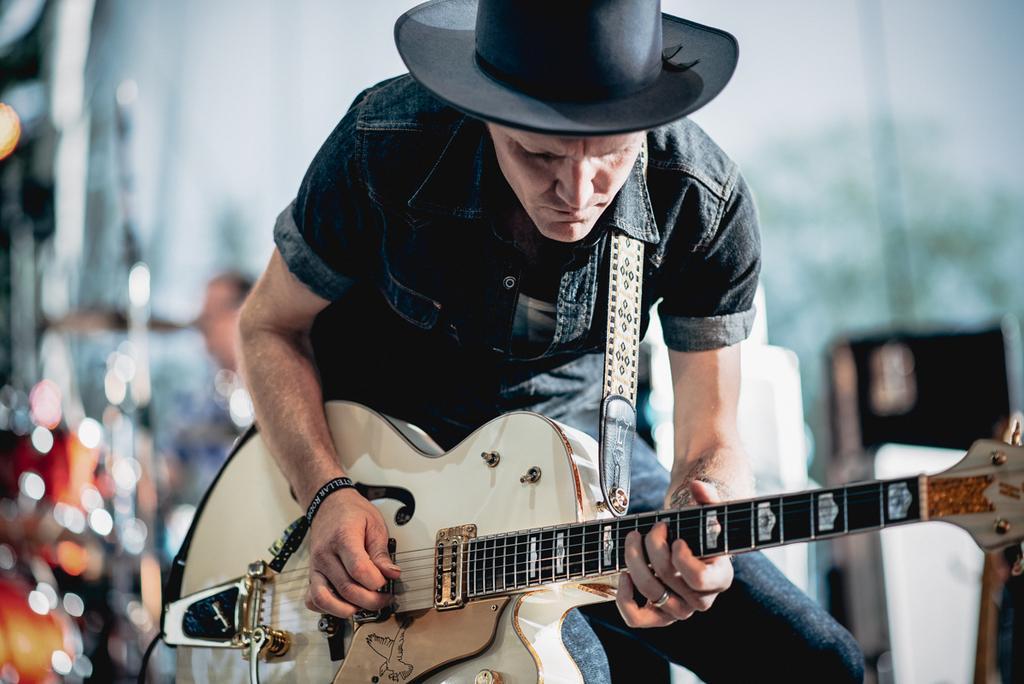In one or two sentences, can you explain what this image depicts? In this image their is a man who is playing the guitar with his hand and he has a cap on his head. 